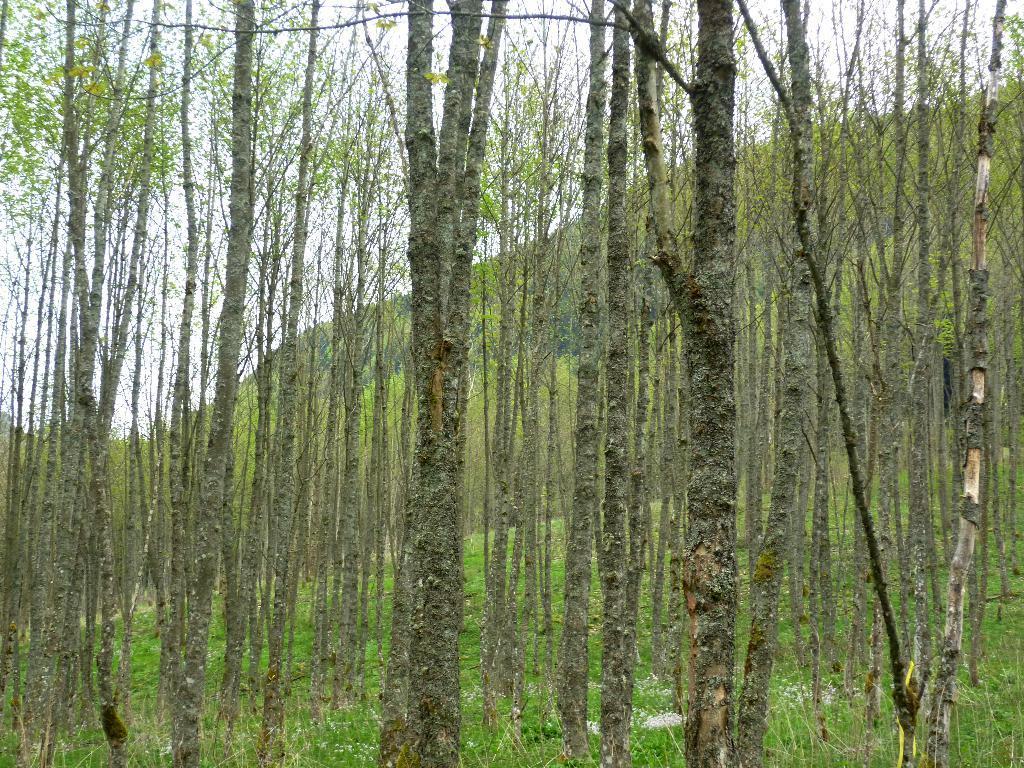Describe this image in one or two sentences. In this image, we can see tall trees and grass. We can also see the sky. 